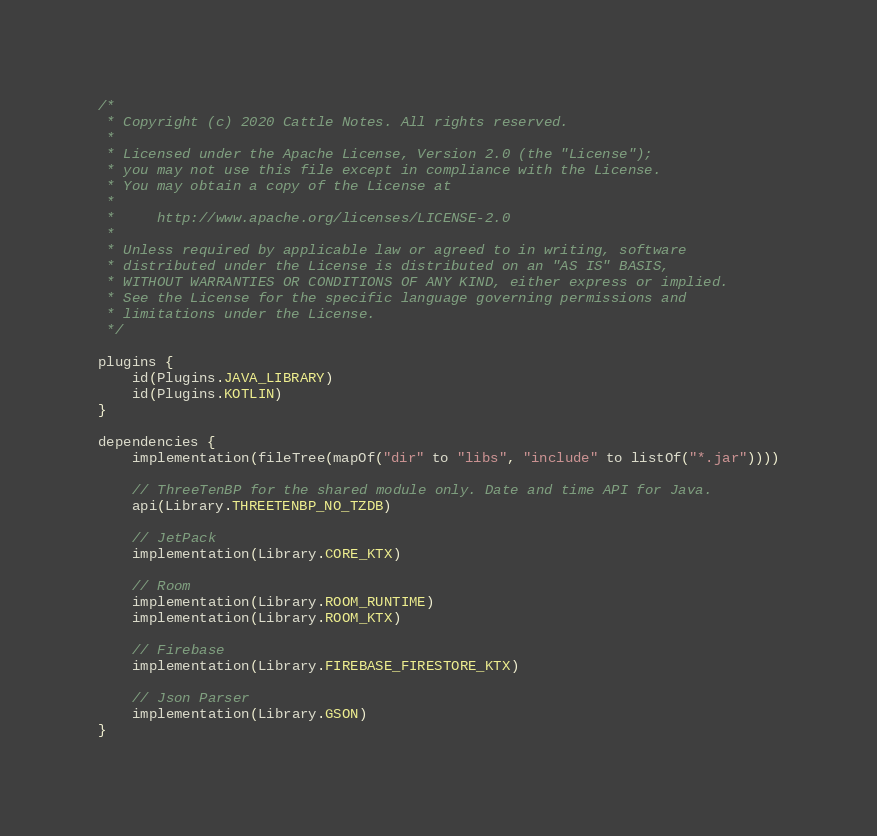<code> <loc_0><loc_0><loc_500><loc_500><_Kotlin_>/*
 * Copyright (c) 2020 Cattle Notes. All rights reserved.
 *
 * Licensed under the Apache License, Version 2.0 (the "License");
 * you may not use this file except in compliance with the License.
 * You may obtain a copy of the License at
 *
 *     http://www.apache.org/licenses/LICENSE-2.0
 *
 * Unless required by applicable law or agreed to in writing, software
 * distributed under the License is distributed on an "AS IS" BASIS,
 * WITHOUT WARRANTIES OR CONDITIONS OF ANY KIND, either express or implied.
 * See the License for the specific language governing permissions and
 * limitations under the License.
 */

plugins {
    id(Plugins.JAVA_LIBRARY)
    id(Plugins.KOTLIN)
}

dependencies {
    implementation(fileTree(mapOf("dir" to "libs", "include" to listOf("*.jar"))))

    // ThreeTenBP for the shared module only. Date and time API for Java.
    api(Library.THREETENBP_NO_TZDB)

    // JetPack
    implementation(Library.CORE_KTX)

    // Room
    implementation(Library.ROOM_RUNTIME)
    implementation(Library.ROOM_KTX)

    // Firebase
    implementation(Library.FIREBASE_FIRESTORE_KTX)

    // Json Parser
    implementation(Library.GSON)
}
</code> 